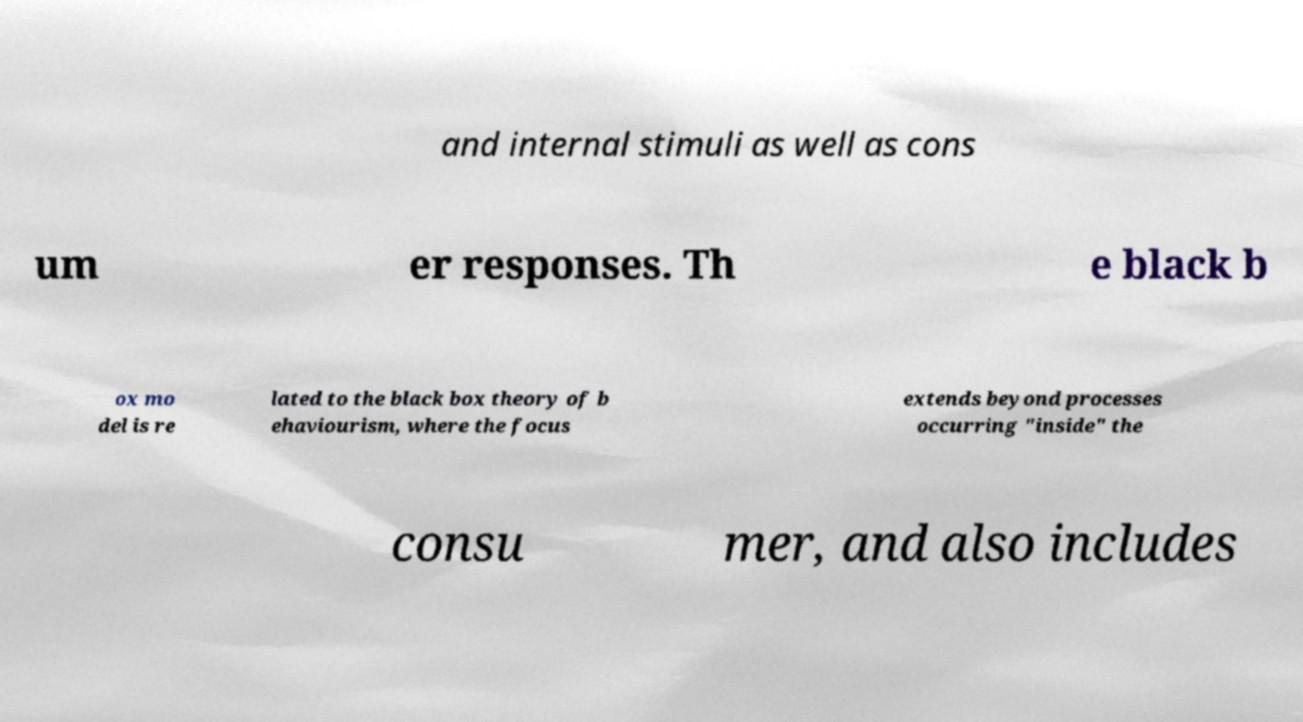Could you extract and type out the text from this image? and internal stimuli as well as cons um er responses. Th e black b ox mo del is re lated to the black box theory of b ehaviourism, where the focus extends beyond processes occurring "inside" the consu mer, and also includes 